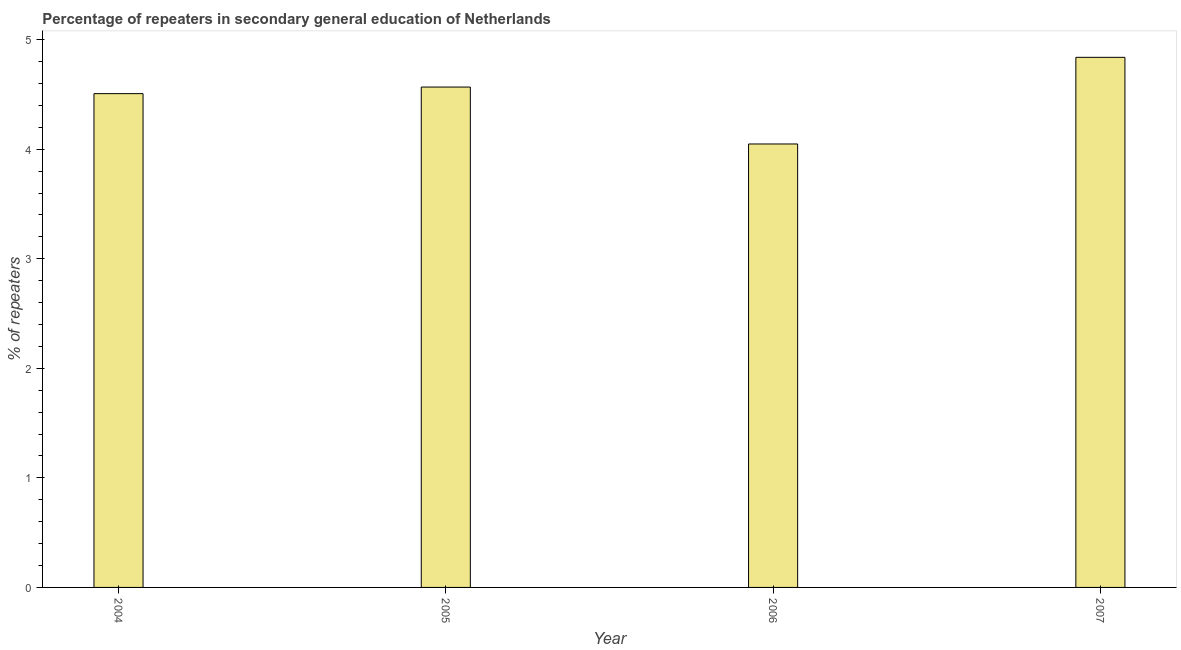What is the title of the graph?
Your response must be concise. Percentage of repeaters in secondary general education of Netherlands. What is the label or title of the X-axis?
Offer a terse response. Year. What is the label or title of the Y-axis?
Your answer should be compact. % of repeaters. What is the percentage of repeaters in 2007?
Give a very brief answer. 4.84. Across all years, what is the maximum percentage of repeaters?
Provide a short and direct response. 4.84. Across all years, what is the minimum percentage of repeaters?
Give a very brief answer. 4.05. In which year was the percentage of repeaters maximum?
Provide a short and direct response. 2007. In which year was the percentage of repeaters minimum?
Keep it short and to the point. 2006. What is the sum of the percentage of repeaters?
Make the answer very short. 17.96. What is the difference between the percentage of repeaters in 2005 and 2007?
Provide a succinct answer. -0.27. What is the average percentage of repeaters per year?
Provide a short and direct response. 4.49. What is the median percentage of repeaters?
Your answer should be very brief. 4.54. In how many years, is the percentage of repeaters greater than 4.4 %?
Keep it short and to the point. 3. Do a majority of the years between 2006 and 2005 (inclusive) have percentage of repeaters greater than 0.2 %?
Your response must be concise. No. What is the ratio of the percentage of repeaters in 2005 to that in 2007?
Make the answer very short. 0.94. Is the percentage of repeaters in 2006 less than that in 2007?
Your response must be concise. Yes. What is the difference between the highest and the second highest percentage of repeaters?
Your response must be concise. 0.27. Is the sum of the percentage of repeaters in 2004 and 2005 greater than the maximum percentage of repeaters across all years?
Make the answer very short. Yes. What is the difference between the highest and the lowest percentage of repeaters?
Keep it short and to the point. 0.79. How many bars are there?
Ensure brevity in your answer.  4. Are the values on the major ticks of Y-axis written in scientific E-notation?
Offer a terse response. No. What is the % of repeaters of 2004?
Give a very brief answer. 4.51. What is the % of repeaters in 2005?
Ensure brevity in your answer.  4.57. What is the % of repeaters in 2006?
Provide a short and direct response. 4.05. What is the % of repeaters in 2007?
Offer a very short reply. 4.84. What is the difference between the % of repeaters in 2004 and 2005?
Offer a very short reply. -0.06. What is the difference between the % of repeaters in 2004 and 2006?
Give a very brief answer. 0.46. What is the difference between the % of repeaters in 2004 and 2007?
Make the answer very short. -0.33. What is the difference between the % of repeaters in 2005 and 2006?
Your answer should be compact. 0.52. What is the difference between the % of repeaters in 2005 and 2007?
Your response must be concise. -0.27. What is the difference between the % of repeaters in 2006 and 2007?
Provide a short and direct response. -0.79. What is the ratio of the % of repeaters in 2004 to that in 2005?
Your response must be concise. 0.99. What is the ratio of the % of repeaters in 2004 to that in 2006?
Your answer should be very brief. 1.11. What is the ratio of the % of repeaters in 2004 to that in 2007?
Give a very brief answer. 0.93. What is the ratio of the % of repeaters in 2005 to that in 2006?
Your response must be concise. 1.13. What is the ratio of the % of repeaters in 2005 to that in 2007?
Provide a succinct answer. 0.94. What is the ratio of the % of repeaters in 2006 to that in 2007?
Give a very brief answer. 0.84. 